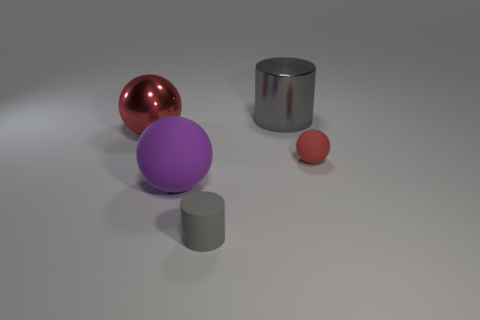What material is the big sphere in front of the red sphere that is in front of the big red sphere made of?
Provide a short and direct response. Rubber. Are there fewer large red metallic objects that are in front of the large red ball than gray objects that are in front of the tiny gray matte cylinder?
Provide a succinct answer. No. How many red things are either large spheres or shiny balls?
Your response must be concise. 1. Are there the same number of small matte spheres that are on the left side of the gray shiny thing and small purple things?
Your answer should be very brief. Yes. How many objects are big blue rubber objects or small rubber objects that are on the left side of the big gray cylinder?
Offer a very short reply. 1. Is the color of the tiny cylinder the same as the large cylinder?
Provide a short and direct response. Yes. Is there a small red thing made of the same material as the tiny gray cylinder?
Offer a terse response. Yes. What color is the tiny rubber object that is the same shape as the large red metallic thing?
Offer a terse response. Red. Is the material of the large purple object the same as the red thing on the left side of the tiny red ball?
Your answer should be very brief. No. There is a large object that is to the right of the small thing that is in front of the tiny red sphere; what shape is it?
Make the answer very short. Cylinder. 